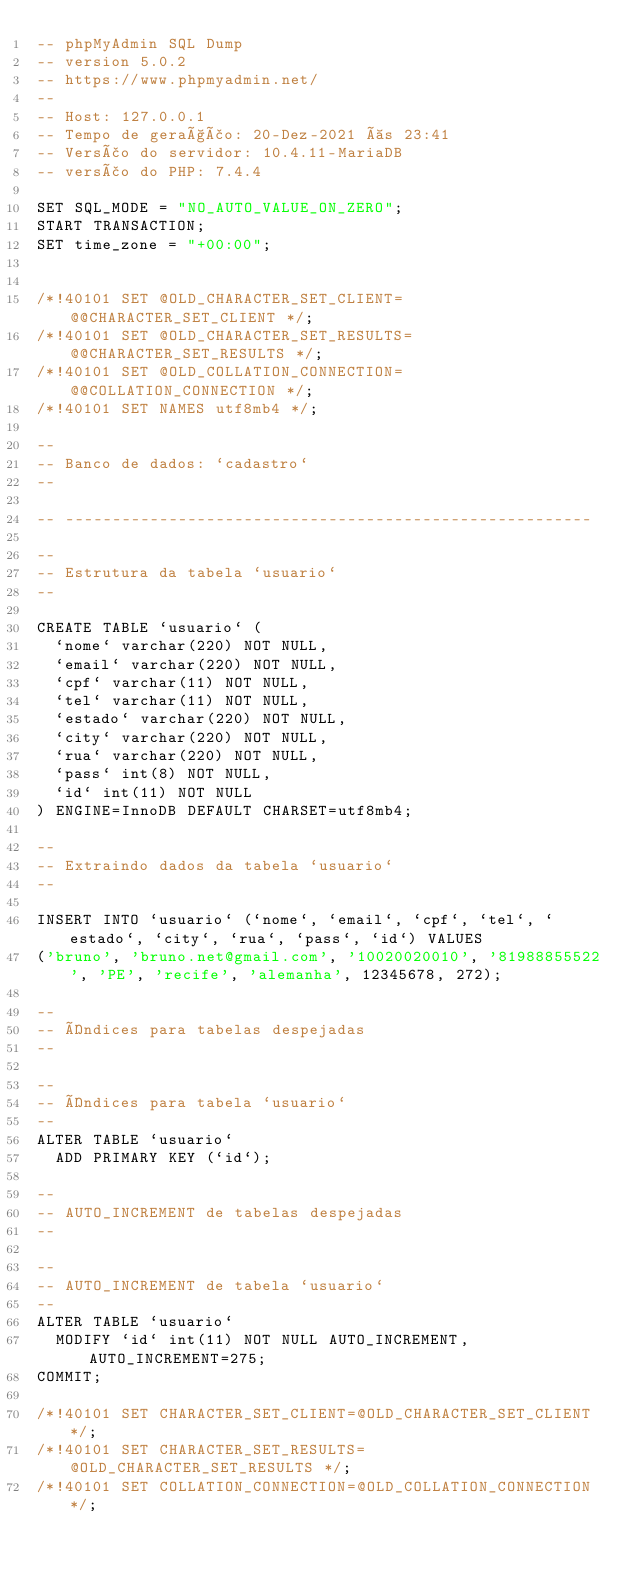<code> <loc_0><loc_0><loc_500><loc_500><_SQL_>-- phpMyAdmin SQL Dump
-- version 5.0.2
-- https://www.phpmyadmin.net/
--
-- Host: 127.0.0.1
-- Tempo de geração: 20-Dez-2021 às 23:41
-- Versão do servidor: 10.4.11-MariaDB
-- versão do PHP: 7.4.4

SET SQL_MODE = "NO_AUTO_VALUE_ON_ZERO";
START TRANSACTION;
SET time_zone = "+00:00";


/*!40101 SET @OLD_CHARACTER_SET_CLIENT=@@CHARACTER_SET_CLIENT */;
/*!40101 SET @OLD_CHARACTER_SET_RESULTS=@@CHARACTER_SET_RESULTS */;
/*!40101 SET @OLD_COLLATION_CONNECTION=@@COLLATION_CONNECTION */;
/*!40101 SET NAMES utf8mb4 */;

--
-- Banco de dados: `cadastro`
--

-- --------------------------------------------------------

--
-- Estrutura da tabela `usuario`
--

CREATE TABLE `usuario` (
  `nome` varchar(220) NOT NULL,
  `email` varchar(220) NOT NULL,
  `cpf` varchar(11) NOT NULL,
  `tel` varchar(11) NOT NULL,
  `estado` varchar(220) NOT NULL,
  `city` varchar(220) NOT NULL,
  `rua` varchar(220) NOT NULL,
  `pass` int(8) NOT NULL,
  `id` int(11) NOT NULL
) ENGINE=InnoDB DEFAULT CHARSET=utf8mb4;

--
-- Extraindo dados da tabela `usuario`
--

INSERT INTO `usuario` (`nome`, `email`, `cpf`, `tel`, `estado`, `city`, `rua`, `pass`, `id`) VALUES
('bruno', 'bruno.net@gmail.com', '10020020010', '81988855522', 'PE', 'recife', 'alemanha', 12345678, 272);

--
-- Índices para tabelas despejadas
--

--
-- Índices para tabela `usuario`
--
ALTER TABLE `usuario`
  ADD PRIMARY KEY (`id`);

--
-- AUTO_INCREMENT de tabelas despejadas
--

--
-- AUTO_INCREMENT de tabela `usuario`
--
ALTER TABLE `usuario`
  MODIFY `id` int(11) NOT NULL AUTO_INCREMENT, AUTO_INCREMENT=275;
COMMIT;

/*!40101 SET CHARACTER_SET_CLIENT=@OLD_CHARACTER_SET_CLIENT */;
/*!40101 SET CHARACTER_SET_RESULTS=@OLD_CHARACTER_SET_RESULTS */;
/*!40101 SET COLLATION_CONNECTION=@OLD_COLLATION_CONNECTION */;
</code> 